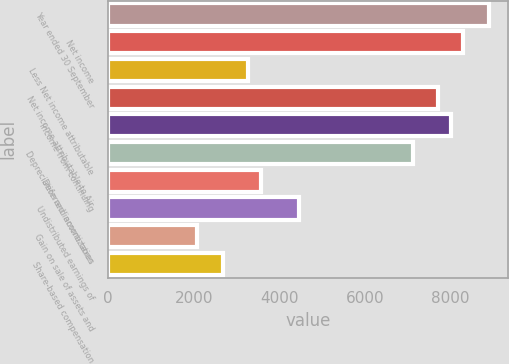<chart> <loc_0><loc_0><loc_500><loc_500><bar_chart><fcel>Year ended 30 September<fcel>Net income<fcel>Less Net income attributable<fcel>Net income attributable to Air<fcel>Income from continuing<fcel>Depreciation and amortization<fcel>Deferred income taxes<fcel>Undistributed earnings of<fcel>Gain on sale of assets and<fcel>Share-based compensation<nl><fcel>8903.7<fcel>8310.32<fcel>3266.59<fcel>7716.94<fcel>8013.63<fcel>7123.56<fcel>3563.28<fcel>4453.35<fcel>2079.83<fcel>2673.21<nl></chart> 